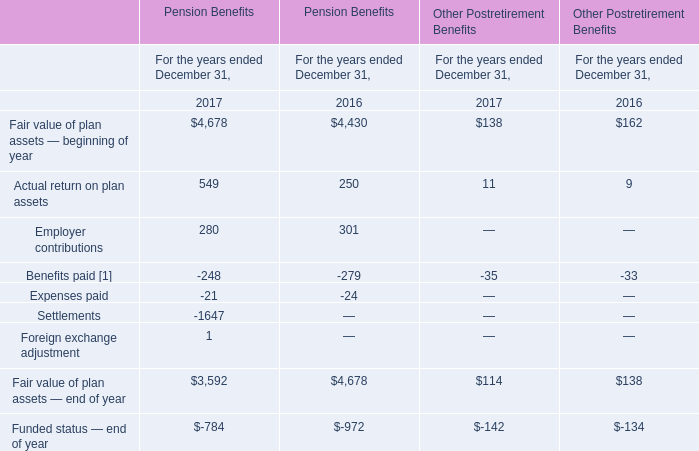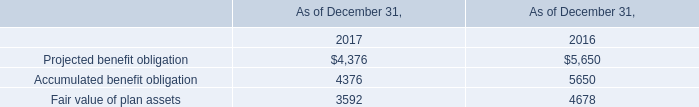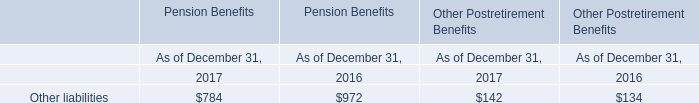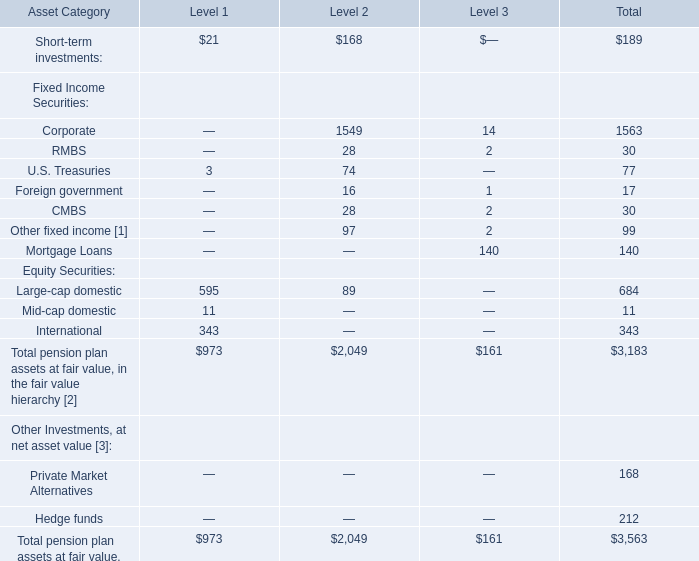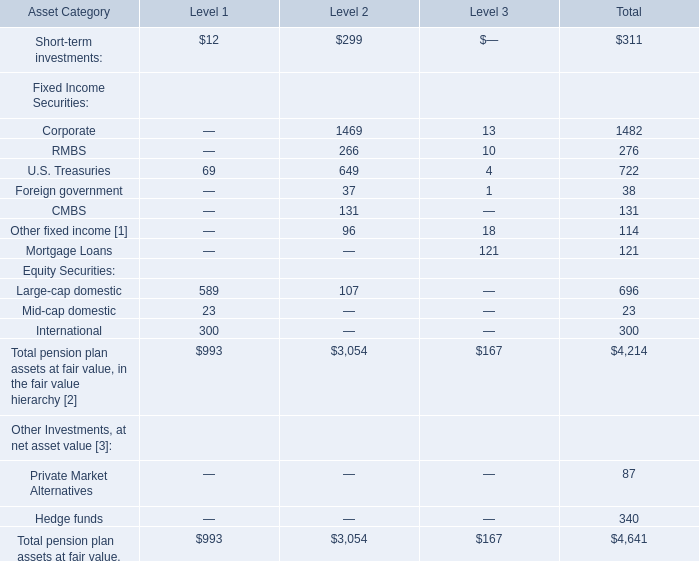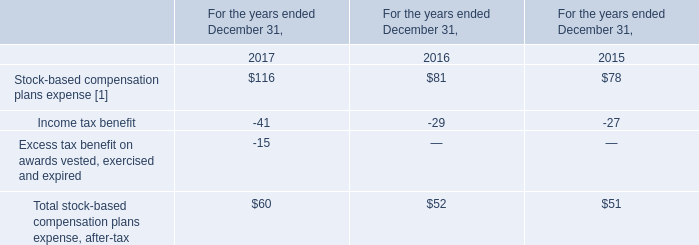What was the total amount of Level 1 excluding those Level 1 greater than 20 for Fixed Income Securities? 
Computations: (3 + 11)
Answer: 14.0. 